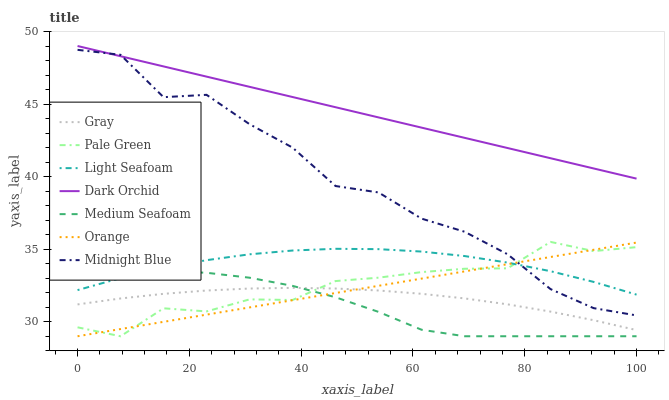Does Medium Seafoam have the minimum area under the curve?
Answer yes or no. Yes. Does Dark Orchid have the maximum area under the curve?
Answer yes or no. Yes. Does Midnight Blue have the minimum area under the curve?
Answer yes or no. No. Does Midnight Blue have the maximum area under the curve?
Answer yes or no. No. Is Orange the smoothest?
Answer yes or no. Yes. Is Midnight Blue the roughest?
Answer yes or no. Yes. Is Dark Orchid the smoothest?
Answer yes or no. No. Is Dark Orchid the roughest?
Answer yes or no. No. Does Pale Green have the lowest value?
Answer yes or no. Yes. Does Midnight Blue have the lowest value?
Answer yes or no. No. Does Dark Orchid have the highest value?
Answer yes or no. Yes. Does Midnight Blue have the highest value?
Answer yes or no. No. Is Gray less than Midnight Blue?
Answer yes or no. Yes. Is Dark Orchid greater than Orange?
Answer yes or no. Yes. Does Dark Orchid intersect Midnight Blue?
Answer yes or no. Yes. Is Dark Orchid less than Midnight Blue?
Answer yes or no. No. Is Dark Orchid greater than Midnight Blue?
Answer yes or no. No. Does Gray intersect Midnight Blue?
Answer yes or no. No. 